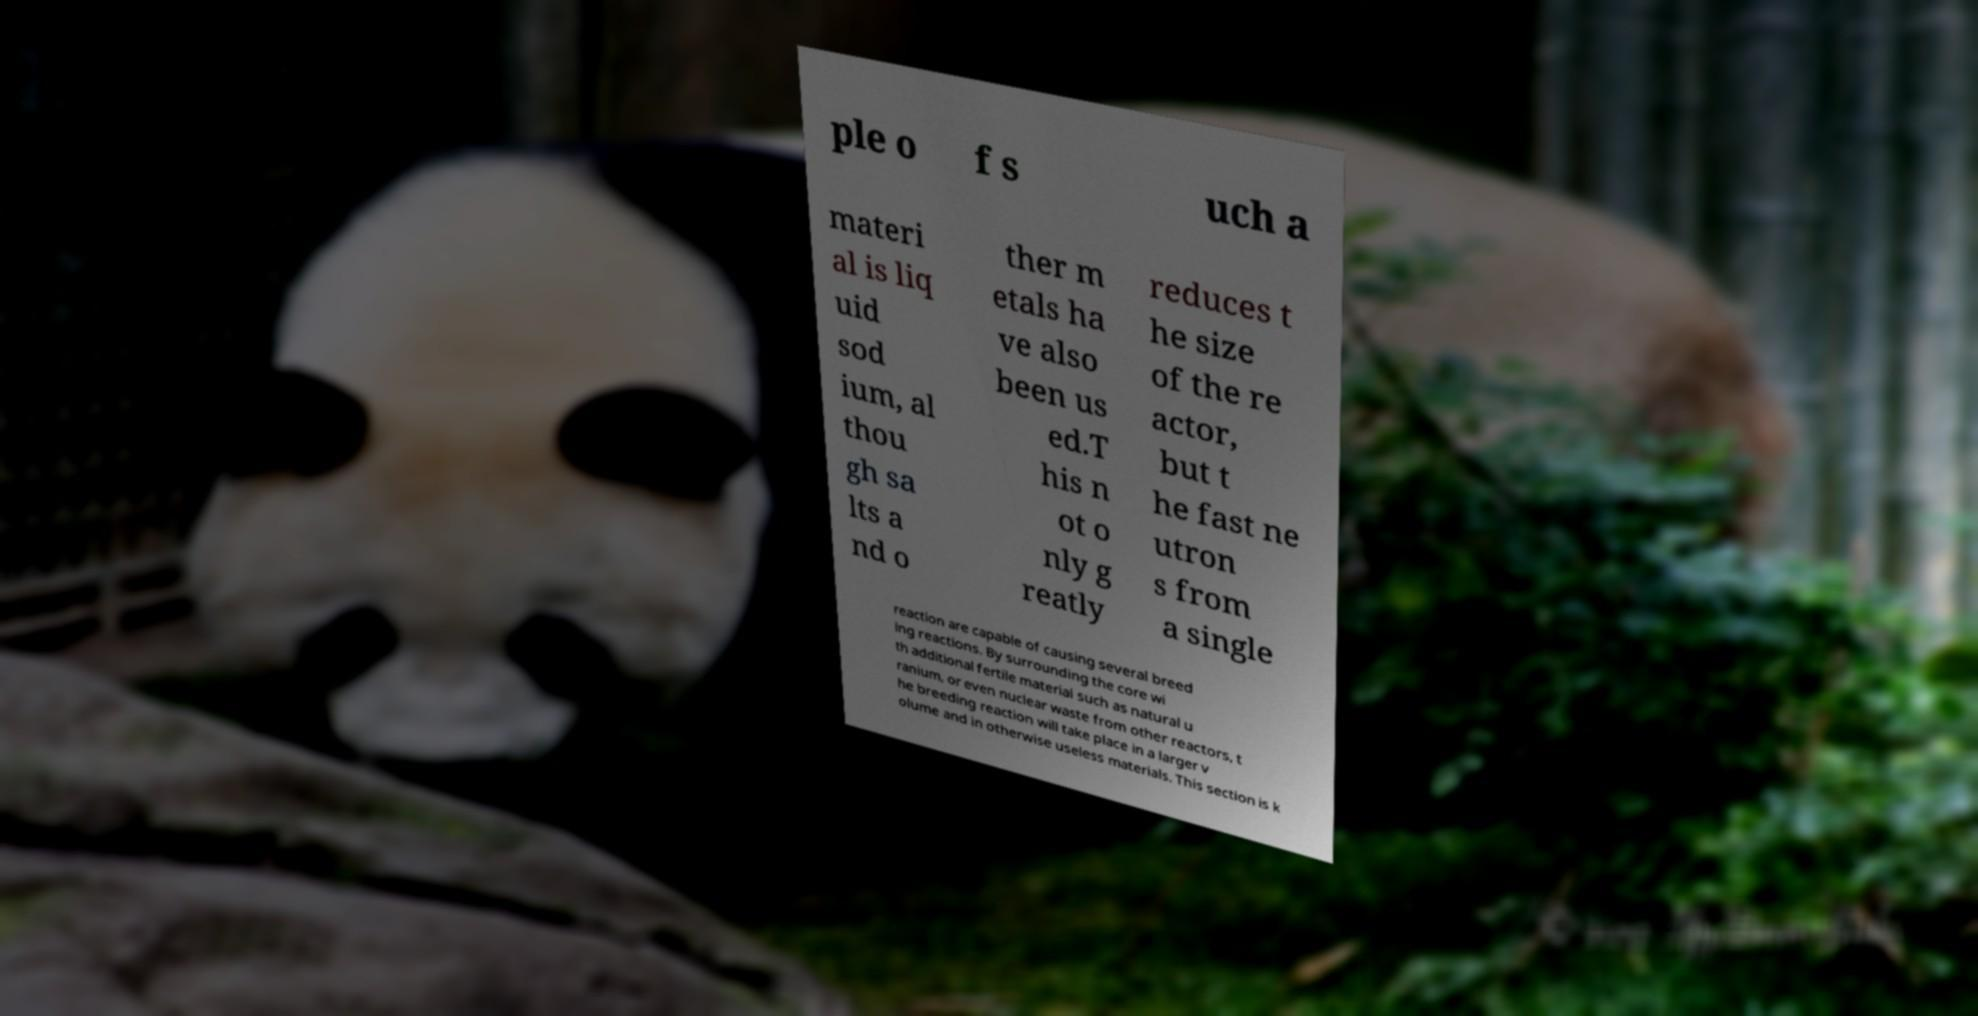What messages or text are displayed in this image? I need them in a readable, typed format. ple o f s uch a materi al is liq uid sod ium, al thou gh sa lts a nd o ther m etals ha ve also been us ed.T his n ot o nly g reatly reduces t he size of the re actor, but t he fast ne utron s from a single reaction are capable of causing several breed ing reactions. By surrounding the core wi th additional fertile material such as natural u ranium, or even nuclear waste from other reactors, t he breeding reaction will take place in a larger v olume and in otherwise useless materials. This section is k 